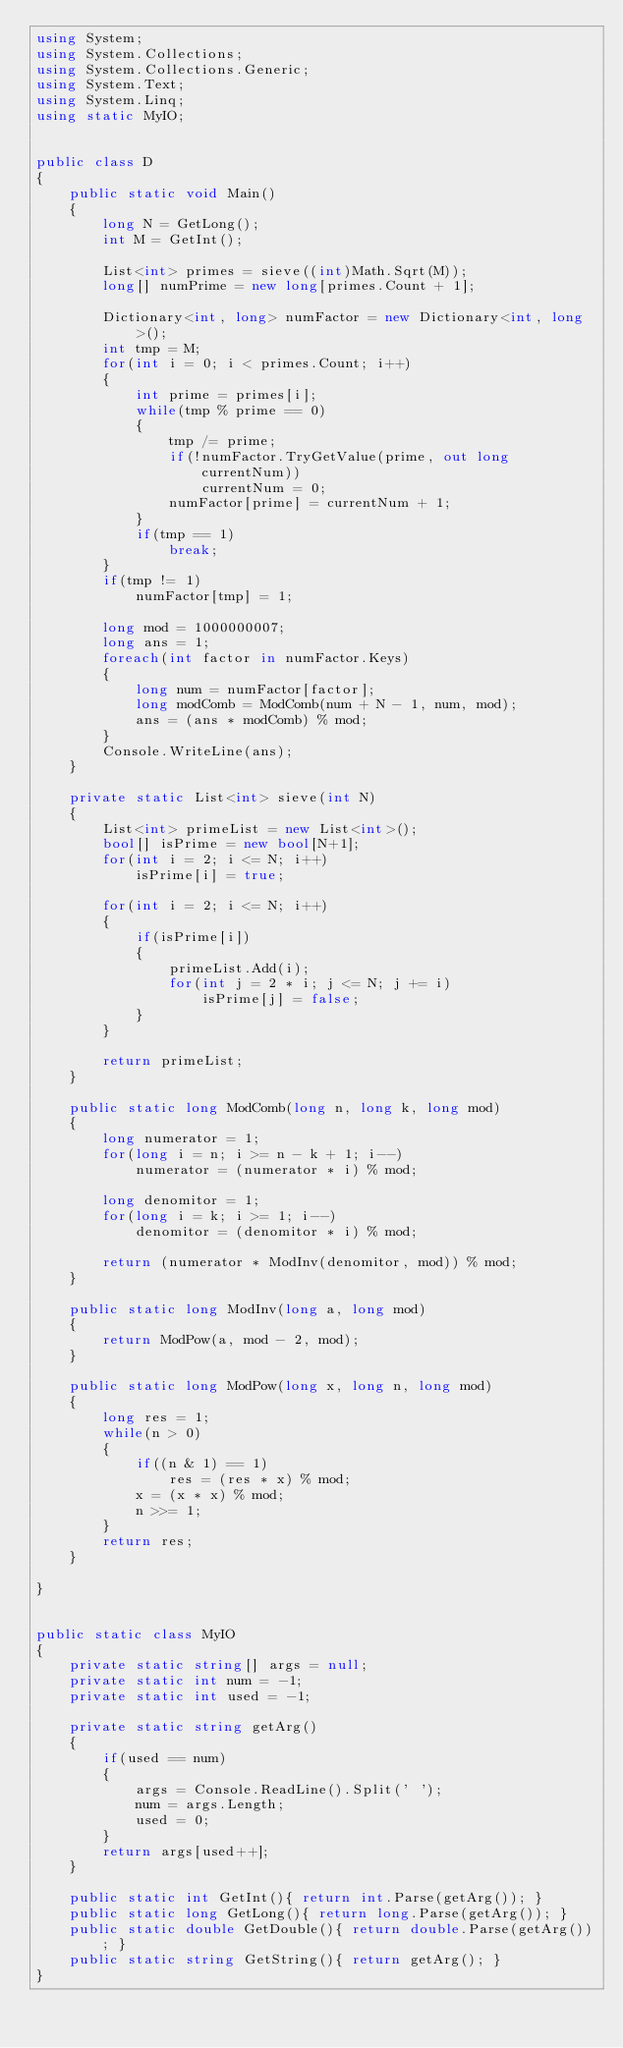Convert code to text. <code><loc_0><loc_0><loc_500><loc_500><_C#_>using System;
using System.Collections;
using System.Collections.Generic;
using System.Text;
using System.Linq;
using static MyIO;


public class D
{
	public static void Main()
	{
		long N = GetLong();
		int M = GetInt();

		List<int> primes = sieve((int)Math.Sqrt(M));
		long[] numPrime = new long[primes.Count + 1];

		Dictionary<int, long> numFactor = new Dictionary<int, long>();
		int tmp = M;
		for(int i = 0; i < primes.Count; i++)
		{
			int prime = primes[i];
			while(tmp % prime == 0)
			{
				tmp /= prime;
				if(!numFactor.TryGetValue(prime, out long currentNum))
					currentNum = 0;
				numFactor[prime] = currentNum + 1;
			}
			if(tmp == 1)
				break;
		}
		if(tmp != 1)
			numFactor[tmp] = 1;		
		
		long mod = 1000000007;
		long ans = 1;
		foreach(int factor in numFactor.Keys)
		{
			long num = numFactor[factor];
			long modComb = ModComb(num + N - 1, num, mod);
			ans = (ans * modComb) % mod;
		}
		Console.WriteLine(ans);
	}

	private static List<int> sieve(int N)
	{
		List<int> primeList = new List<int>();
		bool[] isPrime = new bool[N+1];
		for(int i = 2; i <= N; i++)
			isPrime[i] = true;

		for(int i = 2; i <= N; i++)
		{
			if(isPrime[i])
			{
				primeList.Add(i);
				for(int j = 2 * i; j <= N; j += i)
					isPrime[j] = false;
			}
		}

		return primeList;
	}

	public static long ModComb(long n, long k, long mod)
	{
		long numerator = 1;
		for(long i = n; i >= n - k + 1; i--)
			numerator = (numerator * i) % mod;

		long denomitor = 1;
		for(long i = k; i >= 1; i--)
			denomitor = (denomitor * i) % mod;

		return (numerator * ModInv(denomitor, mod)) % mod;		
	}

	public static long ModInv(long a, long mod)
	{
		return ModPow(a, mod - 2, mod);
	}

	public static long ModPow(long x, long n, long mod)
	{
		long res = 1;
		while(n > 0)
		{
			if((n & 1) == 1)
				res = (res * x) % mod;
			x = (x * x) % mod;
			n >>= 1;
		}
		return res;
	}

}


public static class MyIO
{
	private static string[] args = null;
	private static int num = -1;
	private static int used = -1;

	private static string getArg()
	{
		if(used == num)
		{
			args = Console.ReadLine().Split(' ');
			num = args.Length;
			used = 0;
		}
		return args[used++];
	}

	public static int GetInt(){ return int.Parse(getArg()); }
	public static long GetLong(){ return long.Parse(getArg()); }
	public static double GetDouble(){ return double.Parse(getArg()); }
	public static string GetString(){ return getArg(); }
}



</code> 